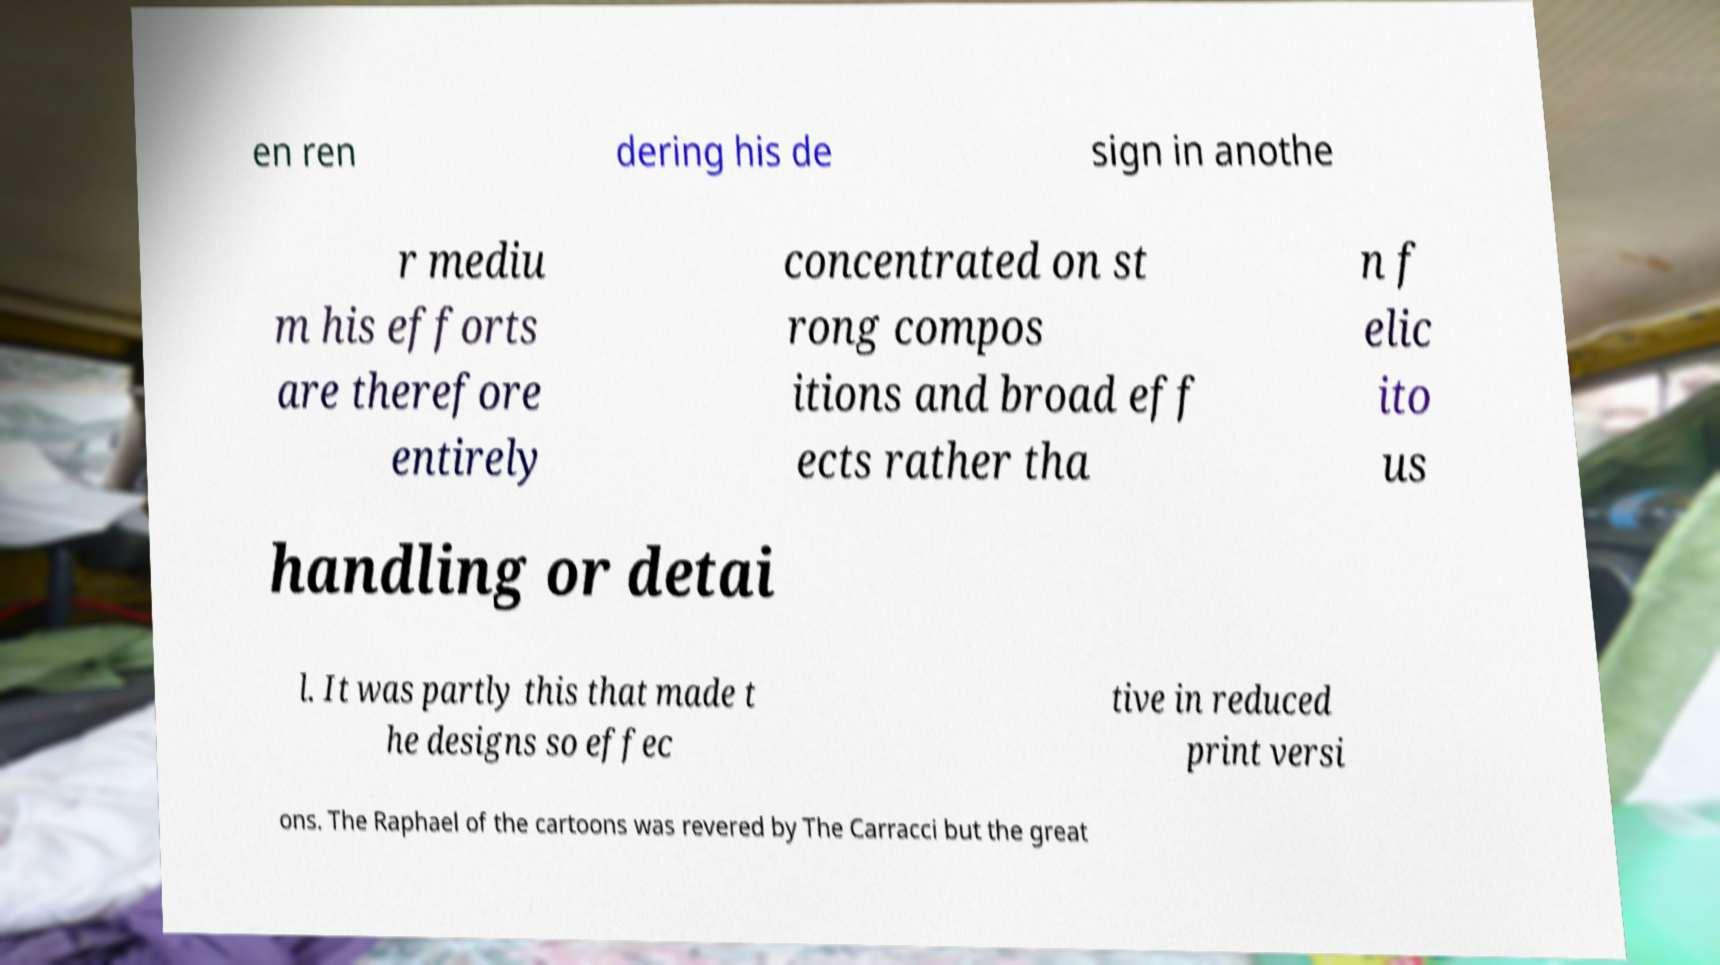There's text embedded in this image that I need extracted. Can you transcribe it verbatim? en ren dering his de sign in anothe r mediu m his efforts are therefore entirely concentrated on st rong compos itions and broad eff ects rather tha n f elic ito us handling or detai l. It was partly this that made t he designs so effec tive in reduced print versi ons. The Raphael of the cartoons was revered by The Carracci but the great 